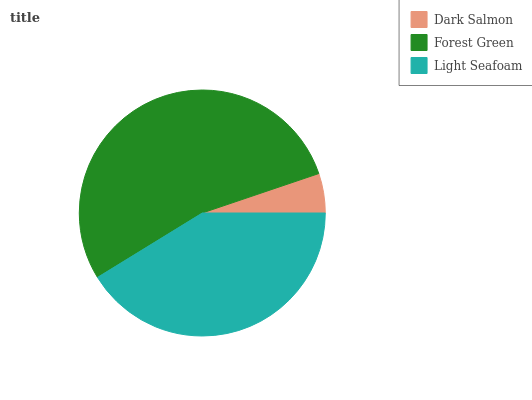Is Dark Salmon the minimum?
Answer yes or no. Yes. Is Forest Green the maximum?
Answer yes or no. Yes. Is Light Seafoam the minimum?
Answer yes or no. No. Is Light Seafoam the maximum?
Answer yes or no. No. Is Forest Green greater than Light Seafoam?
Answer yes or no. Yes. Is Light Seafoam less than Forest Green?
Answer yes or no. Yes. Is Light Seafoam greater than Forest Green?
Answer yes or no. No. Is Forest Green less than Light Seafoam?
Answer yes or no. No. Is Light Seafoam the high median?
Answer yes or no. Yes. Is Light Seafoam the low median?
Answer yes or no. Yes. Is Dark Salmon the high median?
Answer yes or no. No. Is Forest Green the low median?
Answer yes or no. No. 